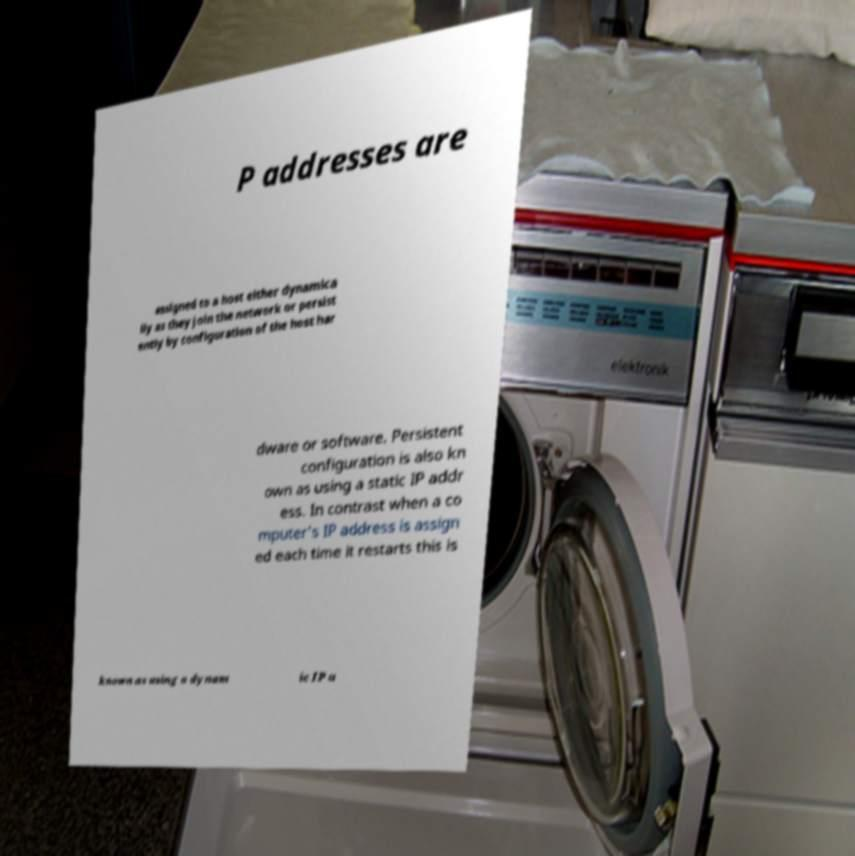I need the written content from this picture converted into text. Can you do that? P addresses are assigned to a host either dynamica lly as they join the network or persist ently by configuration of the host har dware or software. Persistent configuration is also kn own as using a static IP addr ess. In contrast when a co mputer's IP address is assign ed each time it restarts this is known as using a dynam ic IP a 